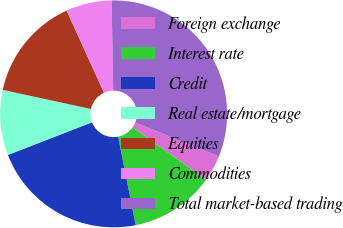Convert chart to OTSL. <chart><loc_0><loc_0><loc_500><loc_500><pie_chart><fcel>Foreign exchange<fcel>Interest rate<fcel>Credit<fcel>Real estate/mortgage<fcel>Equities<fcel>Commodities<fcel>Total market-based trading<nl><fcel>3.74%<fcel>12.04%<fcel>22.22%<fcel>9.28%<fcel>14.81%<fcel>6.51%<fcel>31.4%<nl></chart> 